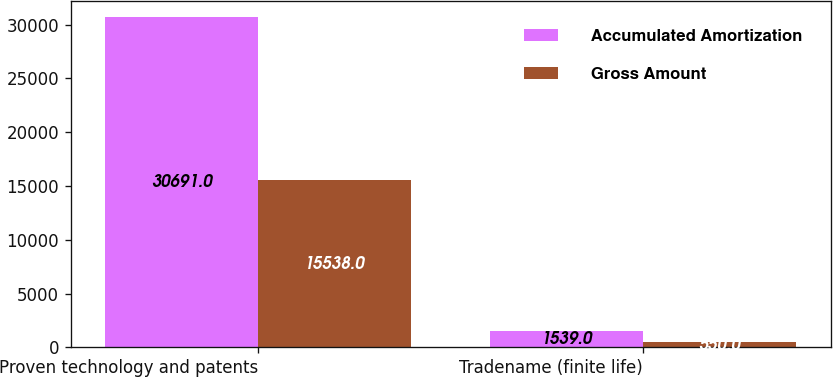Convert chart. <chart><loc_0><loc_0><loc_500><loc_500><stacked_bar_chart><ecel><fcel>Proven technology and patents<fcel>Tradename (finite life)<nl><fcel>Accumulated Amortization<fcel>30691<fcel>1539<nl><fcel>Gross Amount<fcel>15538<fcel>550<nl></chart> 